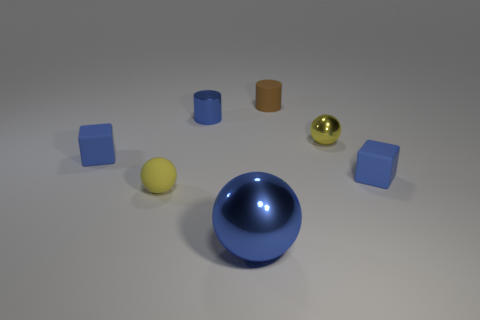There is a blue object on the left side of the yellow rubber sphere; does it have the same size as the yellow rubber thing left of the tiny blue metal cylinder?
Provide a short and direct response. Yes. What size is the yellow metallic thing that is the same shape as the small yellow matte object?
Offer a terse response. Small. Does the brown rubber cylinder have the same size as the matte object right of the small metallic sphere?
Provide a short and direct response. Yes. There is a tiny shiny thing that is in front of the small blue cylinder; is there a tiny blue cylinder that is to the right of it?
Make the answer very short. No. The tiny blue matte thing to the left of the big shiny thing has what shape?
Provide a succinct answer. Cube. There is a tiny object that is the same color as the small shiny sphere; what is it made of?
Offer a very short reply. Rubber. What is the color of the matte object right of the yellow sphere that is on the right side of the large blue metal ball?
Provide a short and direct response. Blue. Do the matte sphere and the yellow shiny object have the same size?
Ensure brevity in your answer.  Yes. There is another object that is the same shape as the brown rubber object; what material is it?
Keep it short and to the point. Metal. What number of balls have the same size as the blue metal cylinder?
Give a very brief answer. 2. 